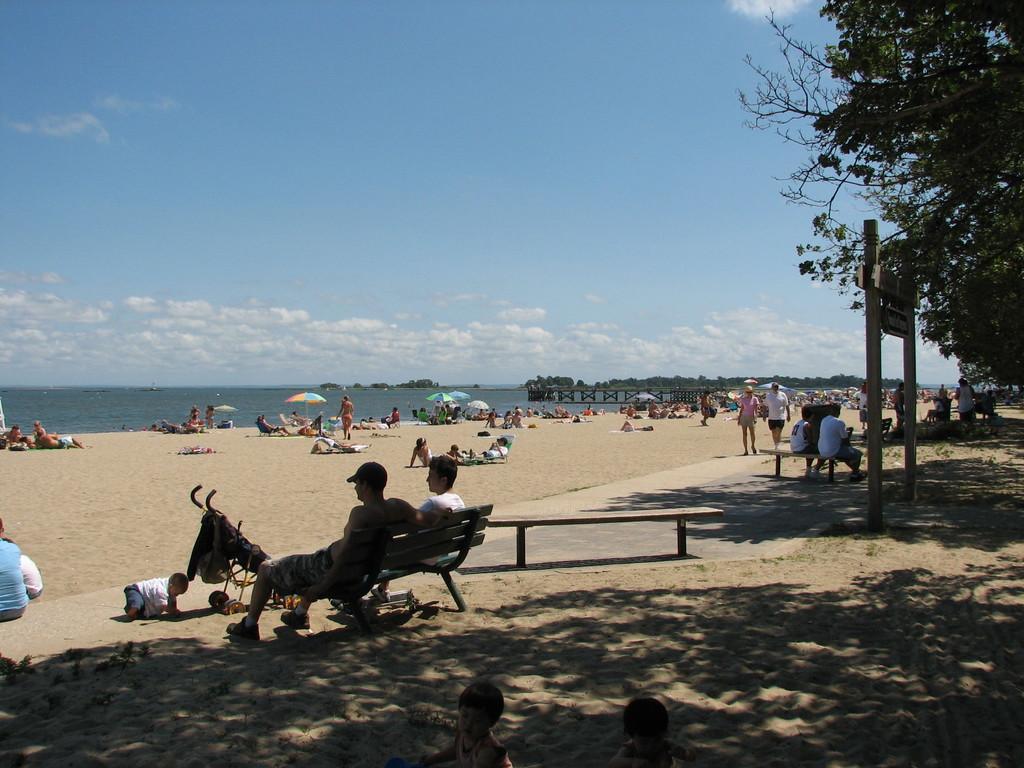Could you give a brief overview of what you see in this image? In this picture there are people, among them few people sitting on benches. We can see sand, umbrellas, trees, water, board, wooden poles and bridge. In the background of the image we can see the sky with clouds. 